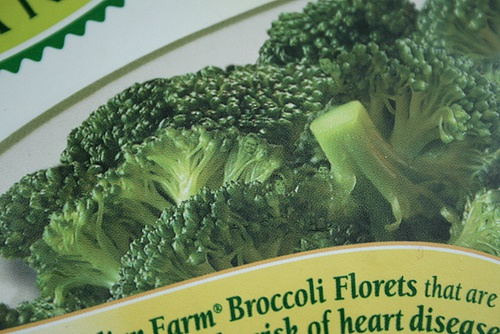Describe the objects in this image and their specific colors. I can see broccoli in olive, darkgreen, green, and black tones, broccoli in olive, darkgreen, and green tones, broccoli in olive, darkgreen, and green tones, broccoli in olive, darkgreen, black, and green tones, and broccoli in olive, green, darkgreen, and lightgreen tones in this image. 